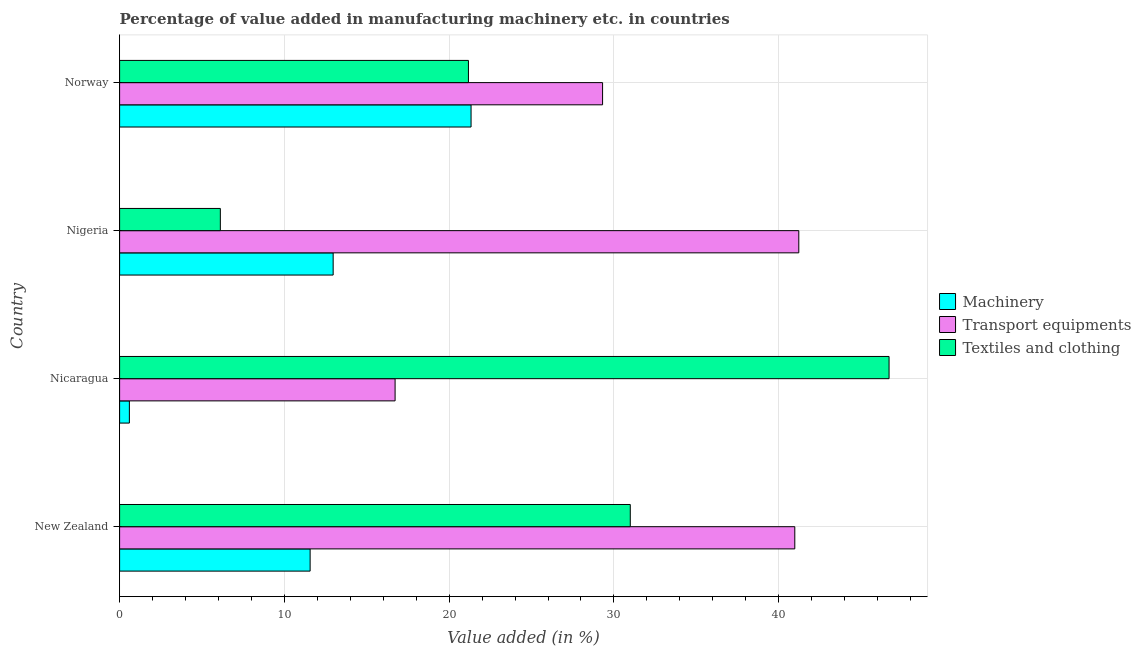How many groups of bars are there?
Keep it short and to the point. 4. Are the number of bars per tick equal to the number of legend labels?
Provide a succinct answer. Yes. Are the number of bars on each tick of the Y-axis equal?
Give a very brief answer. Yes. How many bars are there on the 1st tick from the top?
Your answer should be compact. 3. What is the label of the 1st group of bars from the top?
Give a very brief answer. Norway. In how many cases, is the number of bars for a given country not equal to the number of legend labels?
Your answer should be compact. 0. What is the value added in manufacturing machinery in Nicaragua?
Provide a succinct answer. 0.59. Across all countries, what is the maximum value added in manufacturing machinery?
Give a very brief answer. 21.33. Across all countries, what is the minimum value added in manufacturing textile and clothing?
Your response must be concise. 6.11. In which country was the value added in manufacturing transport equipments maximum?
Offer a very short reply. Nigeria. In which country was the value added in manufacturing textile and clothing minimum?
Offer a very short reply. Nigeria. What is the total value added in manufacturing transport equipments in the graph?
Your answer should be very brief. 128.23. What is the difference between the value added in manufacturing machinery in Nicaragua and that in Norway?
Your response must be concise. -20.74. What is the difference between the value added in manufacturing textile and clothing in Norway and the value added in manufacturing machinery in New Zealand?
Provide a succinct answer. 9.61. What is the average value added in manufacturing textile and clothing per country?
Offer a very short reply. 26.24. What is the difference between the value added in manufacturing transport equipments and value added in manufacturing textile and clothing in Nigeria?
Give a very brief answer. 35.11. In how many countries, is the value added in manufacturing machinery greater than 10 %?
Make the answer very short. 3. What is the ratio of the value added in manufacturing transport equipments in Nicaragua to that in Norway?
Provide a short and direct response. 0.57. Is the value added in manufacturing textile and clothing in New Zealand less than that in Nicaragua?
Keep it short and to the point. Yes. What is the difference between the highest and the second highest value added in manufacturing machinery?
Offer a terse response. 8.37. What is the difference between the highest and the lowest value added in manufacturing machinery?
Offer a terse response. 20.74. Is the sum of the value added in manufacturing transport equipments in Nicaragua and Norway greater than the maximum value added in manufacturing textile and clothing across all countries?
Your answer should be very brief. No. What does the 1st bar from the top in New Zealand represents?
Make the answer very short. Textiles and clothing. What does the 1st bar from the bottom in New Zealand represents?
Offer a terse response. Machinery. Are all the bars in the graph horizontal?
Your answer should be very brief. Yes. How many countries are there in the graph?
Your answer should be very brief. 4. What is the difference between two consecutive major ticks on the X-axis?
Ensure brevity in your answer.  10. Are the values on the major ticks of X-axis written in scientific E-notation?
Provide a succinct answer. No. Does the graph contain any zero values?
Offer a very short reply. No. Does the graph contain grids?
Your answer should be compact. Yes. Where does the legend appear in the graph?
Make the answer very short. Center right. How many legend labels are there?
Your answer should be compact. 3. What is the title of the graph?
Your answer should be compact. Percentage of value added in manufacturing machinery etc. in countries. What is the label or title of the X-axis?
Make the answer very short. Value added (in %). What is the label or title of the Y-axis?
Your answer should be very brief. Country. What is the Value added (in %) in Machinery in New Zealand?
Your answer should be very brief. 11.56. What is the Value added (in %) of Transport equipments in New Zealand?
Keep it short and to the point. 40.98. What is the Value added (in %) in Textiles and clothing in New Zealand?
Your answer should be very brief. 30.99. What is the Value added (in %) of Machinery in Nicaragua?
Offer a terse response. 0.59. What is the Value added (in %) in Transport equipments in Nicaragua?
Your response must be concise. 16.72. What is the Value added (in %) of Textiles and clothing in Nicaragua?
Your answer should be compact. 46.7. What is the Value added (in %) in Machinery in Nigeria?
Your answer should be compact. 12.96. What is the Value added (in %) in Transport equipments in Nigeria?
Keep it short and to the point. 41.22. What is the Value added (in %) of Textiles and clothing in Nigeria?
Provide a succinct answer. 6.11. What is the Value added (in %) of Machinery in Norway?
Your response must be concise. 21.33. What is the Value added (in %) of Transport equipments in Norway?
Offer a very short reply. 29.31. What is the Value added (in %) of Textiles and clothing in Norway?
Your response must be concise. 21.17. Across all countries, what is the maximum Value added (in %) of Machinery?
Your answer should be compact. 21.33. Across all countries, what is the maximum Value added (in %) in Transport equipments?
Offer a terse response. 41.22. Across all countries, what is the maximum Value added (in %) of Textiles and clothing?
Your answer should be very brief. 46.7. Across all countries, what is the minimum Value added (in %) of Machinery?
Your answer should be compact. 0.59. Across all countries, what is the minimum Value added (in %) in Transport equipments?
Offer a terse response. 16.72. Across all countries, what is the minimum Value added (in %) of Textiles and clothing?
Make the answer very short. 6.11. What is the total Value added (in %) in Machinery in the graph?
Offer a very short reply. 46.45. What is the total Value added (in %) in Transport equipments in the graph?
Offer a terse response. 128.23. What is the total Value added (in %) in Textiles and clothing in the graph?
Your response must be concise. 104.98. What is the difference between the Value added (in %) of Machinery in New Zealand and that in Nicaragua?
Give a very brief answer. 10.97. What is the difference between the Value added (in %) in Transport equipments in New Zealand and that in Nicaragua?
Offer a terse response. 24.26. What is the difference between the Value added (in %) of Textiles and clothing in New Zealand and that in Nicaragua?
Give a very brief answer. -15.71. What is the difference between the Value added (in %) of Machinery in New Zealand and that in Nigeria?
Your response must be concise. -1.4. What is the difference between the Value added (in %) in Transport equipments in New Zealand and that in Nigeria?
Provide a succinct answer. -0.24. What is the difference between the Value added (in %) of Textiles and clothing in New Zealand and that in Nigeria?
Give a very brief answer. 24.88. What is the difference between the Value added (in %) in Machinery in New Zealand and that in Norway?
Offer a very short reply. -9.77. What is the difference between the Value added (in %) of Transport equipments in New Zealand and that in Norway?
Make the answer very short. 11.67. What is the difference between the Value added (in %) in Textiles and clothing in New Zealand and that in Norway?
Your answer should be very brief. 9.82. What is the difference between the Value added (in %) of Machinery in Nicaragua and that in Nigeria?
Give a very brief answer. -12.37. What is the difference between the Value added (in %) in Transport equipments in Nicaragua and that in Nigeria?
Give a very brief answer. -24.5. What is the difference between the Value added (in %) of Textiles and clothing in Nicaragua and that in Nigeria?
Your answer should be very brief. 40.58. What is the difference between the Value added (in %) of Machinery in Nicaragua and that in Norway?
Provide a succinct answer. -20.74. What is the difference between the Value added (in %) in Transport equipments in Nicaragua and that in Norway?
Offer a very short reply. -12.59. What is the difference between the Value added (in %) in Textiles and clothing in Nicaragua and that in Norway?
Provide a succinct answer. 25.53. What is the difference between the Value added (in %) in Machinery in Nigeria and that in Norway?
Your answer should be compact. -8.37. What is the difference between the Value added (in %) in Transport equipments in Nigeria and that in Norway?
Ensure brevity in your answer.  11.91. What is the difference between the Value added (in %) of Textiles and clothing in Nigeria and that in Norway?
Give a very brief answer. -15.06. What is the difference between the Value added (in %) of Machinery in New Zealand and the Value added (in %) of Transport equipments in Nicaragua?
Offer a very short reply. -5.16. What is the difference between the Value added (in %) in Machinery in New Zealand and the Value added (in %) in Textiles and clothing in Nicaragua?
Ensure brevity in your answer.  -35.14. What is the difference between the Value added (in %) in Transport equipments in New Zealand and the Value added (in %) in Textiles and clothing in Nicaragua?
Keep it short and to the point. -5.72. What is the difference between the Value added (in %) in Machinery in New Zealand and the Value added (in %) in Transport equipments in Nigeria?
Offer a very short reply. -29.66. What is the difference between the Value added (in %) in Machinery in New Zealand and the Value added (in %) in Textiles and clothing in Nigeria?
Your response must be concise. 5.45. What is the difference between the Value added (in %) of Transport equipments in New Zealand and the Value added (in %) of Textiles and clothing in Nigeria?
Provide a succinct answer. 34.86. What is the difference between the Value added (in %) of Machinery in New Zealand and the Value added (in %) of Transport equipments in Norway?
Give a very brief answer. -17.75. What is the difference between the Value added (in %) of Machinery in New Zealand and the Value added (in %) of Textiles and clothing in Norway?
Give a very brief answer. -9.61. What is the difference between the Value added (in %) of Transport equipments in New Zealand and the Value added (in %) of Textiles and clothing in Norway?
Give a very brief answer. 19.81. What is the difference between the Value added (in %) of Machinery in Nicaragua and the Value added (in %) of Transport equipments in Nigeria?
Make the answer very short. -40.63. What is the difference between the Value added (in %) in Machinery in Nicaragua and the Value added (in %) in Textiles and clothing in Nigeria?
Make the answer very short. -5.52. What is the difference between the Value added (in %) of Transport equipments in Nicaragua and the Value added (in %) of Textiles and clothing in Nigeria?
Keep it short and to the point. 10.61. What is the difference between the Value added (in %) in Machinery in Nicaragua and the Value added (in %) in Transport equipments in Norway?
Provide a succinct answer. -28.72. What is the difference between the Value added (in %) in Machinery in Nicaragua and the Value added (in %) in Textiles and clothing in Norway?
Give a very brief answer. -20.58. What is the difference between the Value added (in %) in Transport equipments in Nicaragua and the Value added (in %) in Textiles and clothing in Norway?
Make the answer very short. -4.45. What is the difference between the Value added (in %) in Machinery in Nigeria and the Value added (in %) in Transport equipments in Norway?
Your answer should be compact. -16.35. What is the difference between the Value added (in %) of Machinery in Nigeria and the Value added (in %) of Textiles and clothing in Norway?
Offer a very short reply. -8.21. What is the difference between the Value added (in %) of Transport equipments in Nigeria and the Value added (in %) of Textiles and clothing in Norway?
Offer a terse response. 20.05. What is the average Value added (in %) in Machinery per country?
Provide a short and direct response. 11.61. What is the average Value added (in %) in Transport equipments per country?
Your response must be concise. 32.06. What is the average Value added (in %) in Textiles and clothing per country?
Give a very brief answer. 26.24. What is the difference between the Value added (in %) of Machinery and Value added (in %) of Transport equipments in New Zealand?
Provide a succinct answer. -29.41. What is the difference between the Value added (in %) of Machinery and Value added (in %) of Textiles and clothing in New Zealand?
Your response must be concise. -19.43. What is the difference between the Value added (in %) of Transport equipments and Value added (in %) of Textiles and clothing in New Zealand?
Offer a very short reply. 9.98. What is the difference between the Value added (in %) of Machinery and Value added (in %) of Transport equipments in Nicaragua?
Keep it short and to the point. -16.13. What is the difference between the Value added (in %) in Machinery and Value added (in %) in Textiles and clothing in Nicaragua?
Your answer should be compact. -46.11. What is the difference between the Value added (in %) of Transport equipments and Value added (in %) of Textiles and clothing in Nicaragua?
Provide a succinct answer. -29.98. What is the difference between the Value added (in %) of Machinery and Value added (in %) of Transport equipments in Nigeria?
Make the answer very short. -28.26. What is the difference between the Value added (in %) in Machinery and Value added (in %) in Textiles and clothing in Nigeria?
Offer a terse response. 6.85. What is the difference between the Value added (in %) in Transport equipments and Value added (in %) in Textiles and clothing in Nigeria?
Give a very brief answer. 35.11. What is the difference between the Value added (in %) in Machinery and Value added (in %) in Transport equipments in Norway?
Make the answer very short. -7.98. What is the difference between the Value added (in %) in Machinery and Value added (in %) in Textiles and clothing in Norway?
Your answer should be very brief. 0.16. What is the difference between the Value added (in %) in Transport equipments and Value added (in %) in Textiles and clothing in Norway?
Offer a very short reply. 8.14. What is the ratio of the Value added (in %) in Machinery in New Zealand to that in Nicaragua?
Make the answer very short. 19.49. What is the ratio of the Value added (in %) of Transport equipments in New Zealand to that in Nicaragua?
Offer a very short reply. 2.45. What is the ratio of the Value added (in %) of Textiles and clothing in New Zealand to that in Nicaragua?
Provide a succinct answer. 0.66. What is the ratio of the Value added (in %) in Machinery in New Zealand to that in Nigeria?
Give a very brief answer. 0.89. What is the ratio of the Value added (in %) of Transport equipments in New Zealand to that in Nigeria?
Provide a succinct answer. 0.99. What is the ratio of the Value added (in %) of Textiles and clothing in New Zealand to that in Nigeria?
Offer a very short reply. 5.07. What is the ratio of the Value added (in %) in Machinery in New Zealand to that in Norway?
Your response must be concise. 0.54. What is the ratio of the Value added (in %) in Transport equipments in New Zealand to that in Norway?
Offer a very short reply. 1.4. What is the ratio of the Value added (in %) in Textiles and clothing in New Zealand to that in Norway?
Make the answer very short. 1.46. What is the ratio of the Value added (in %) in Machinery in Nicaragua to that in Nigeria?
Give a very brief answer. 0.05. What is the ratio of the Value added (in %) in Transport equipments in Nicaragua to that in Nigeria?
Provide a succinct answer. 0.41. What is the ratio of the Value added (in %) in Textiles and clothing in Nicaragua to that in Nigeria?
Provide a succinct answer. 7.64. What is the ratio of the Value added (in %) of Machinery in Nicaragua to that in Norway?
Provide a short and direct response. 0.03. What is the ratio of the Value added (in %) in Transport equipments in Nicaragua to that in Norway?
Ensure brevity in your answer.  0.57. What is the ratio of the Value added (in %) of Textiles and clothing in Nicaragua to that in Norway?
Offer a very short reply. 2.21. What is the ratio of the Value added (in %) of Machinery in Nigeria to that in Norway?
Ensure brevity in your answer.  0.61. What is the ratio of the Value added (in %) in Transport equipments in Nigeria to that in Norway?
Provide a succinct answer. 1.41. What is the ratio of the Value added (in %) of Textiles and clothing in Nigeria to that in Norway?
Provide a short and direct response. 0.29. What is the difference between the highest and the second highest Value added (in %) in Machinery?
Keep it short and to the point. 8.37. What is the difference between the highest and the second highest Value added (in %) in Transport equipments?
Your response must be concise. 0.24. What is the difference between the highest and the second highest Value added (in %) of Textiles and clothing?
Provide a succinct answer. 15.71. What is the difference between the highest and the lowest Value added (in %) of Machinery?
Offer a terse response. 20.74. What is the difference between the highest and the lowest Value added (in %) of Transport equipments?
Give a very brief answer. 24.5. What is the difference between the highest and the lowest Value added (in %) in Textiles and clothing?
Ensure brevity in your answer.  40.58. 